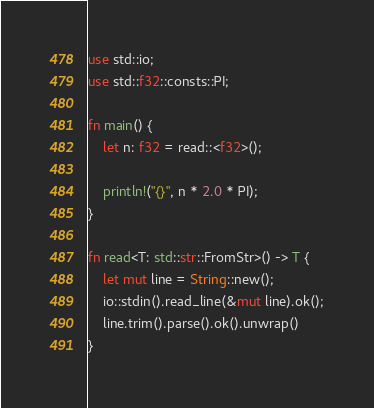<code> <loc_0><loc_0><loc_500><loc_500><_Rust_>use std::io;
use std::f32::consts::PI;

fn main() {
    let n: f32 = read::<f32>();

    println!("{}", n * 2.0 * PI);
}

fn read<T: std::str::FromStr>() -> T {
    let mut line = String::new();
    io::stdin().read_line(&mut line).ok();
    line.trim().parse().ok().unwrap()
}</code> 